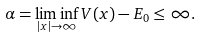<formula> <loc_0><loc_0><loc_500><loc_500>\alpha = \liminf _ { | x | \to \infty } V ( x ) - E _ { 0 } \leq \infty .</formula> 